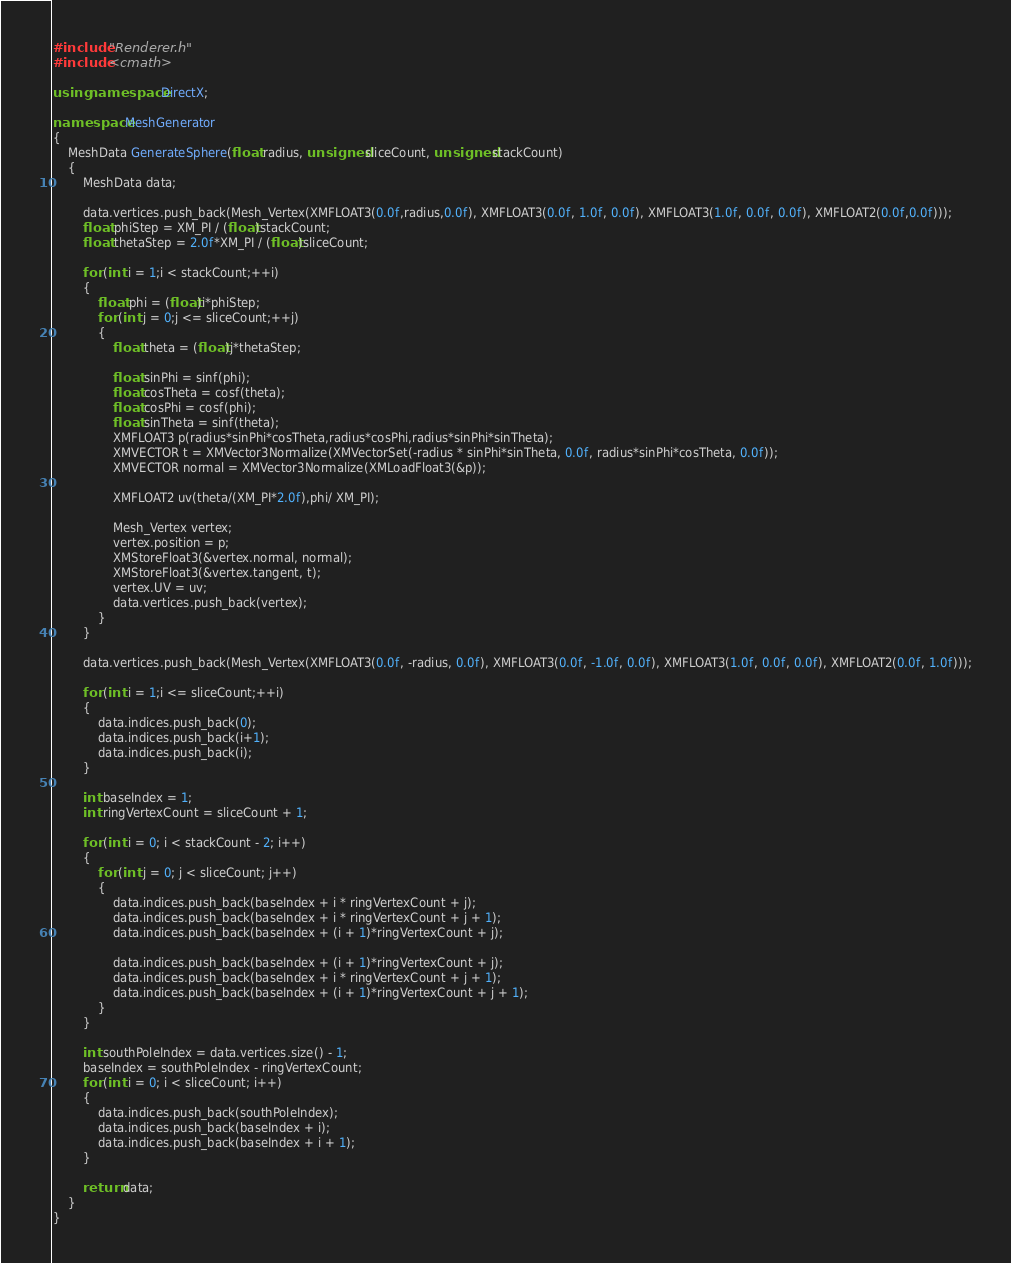Convert code to text. <code><loc_0><loc_0><loc_500><loc_500><_C++_>#include "Renderer.h"
#include <cmath>

using namespace DirectX;

namespace MeshGenerator
{
	MeshData GenerateSphere(float radius, unsigned sliceCount, unsigned stackCount)
	{
		MeshData data;

		data.vertices.push_back(Mesh_Vertex(XMFLOAT3(0.0f,radius,0.0f), XMFLOAT3(0.0f, 1.0f, 0.0f), XMFLOAT3(1.0f, 0.0f, 0.0f), XMFLOAT2(0.0f,0.0f)));
		float phiStep = XM_PI / (float)stackCount;
		float thetaStep = 2.0f*XM_PI / (float)sliceCount;

		for (int i = 1;i < stackCount;++i)
		{
			float phi = (float)i*phiStep;
			for (int j = 0;j <= sliceCount;++j)
			{
				float theta = (float)j*thetaStep;

				float sinPhi = sinf(phi);
				float cosTheta = cosf(theta);
				float cosPhi = cosf(phi);
				float sinTheta = sinf(theta);
				XMFLOAT3 p(radius*sinPhi*cosTheta,radius*cosPhi,radius*sinPhi*sinTheta);
				XMVECTOR t = XMVector3Normalize(XMVectorSet(-radius * sinPhi*sinTheta, 0.0f, radius*sinPhi*cosTheta, 0.0f));
				XMVECTOR normal = XMVector3Normalize(XMLoadFloat3(&p));

				XMFLOAT2 uv(theta/(XM_PI*2.0f),phi/ XM_PI);

				Mesh_Vertex vertex;
				vertex.position = p;
				XMStoreFloat3(&vertex.normal, normal);
				XMStoreFloat3(&vertex.tangent, t);
				vertex.UV = uv;
				data.vertices.push_back(vertex);
			}
		}

		data.vertices.push_back(Mesh_Vertex(XMFLOAT3(0.0f, -radius, 0.0f), XMFLOAT3(0.0f, -1.0f, 0.0f), XMFLOAT3(1.0f, 0.0f, 0.0f), XMFLOAT2(0.0f, 1.0f)));

		for (int i = 1;i <= sliceCount;++i)
		{
			data.indices.push_back(0);
			data.indices.push_back(i+1);
			data.indices.push_back(i);
		}

		int baseIndex = 1;
		int ringVertexCount = sliceCount + 1;

		for (int i = 0; i < stackCount - 2; i++)
		{
			for (int j = 0; j < sliceCount; j++)
			{
				data.indices.push_back(baseIndex + i * ringVertexCount + j);
				data.indices.push_back(baseIndex + i * ringVertexCount + j + 1);
				data.indices.push_back(baseIndex + (i + 1)*ringVertexCount + j);

				data.indices.push_back(baseIndex + (i + 1)*ringVertexCount + j);
				data.indices.push_back(baseIndex + i * ringVertexCount + j + 1);
				data.indices.push_back(baseIndex + (i + 1)*ringVertexCount + j + 1);
			}
		}

		int southPoleIndex = data.vertices.size() - 1;
		baseIndex = southPoleIndex - ringVertexCount;
		for (int i = 0; i < sliceCount; i++)
		{
			data.indices.push_back(southPoleIndex);
			data.indices.push_back(baseIndex + i);
			data.indices.push_back(baseIndex + i + 1);
		}

		return data;
	}
}</code> 